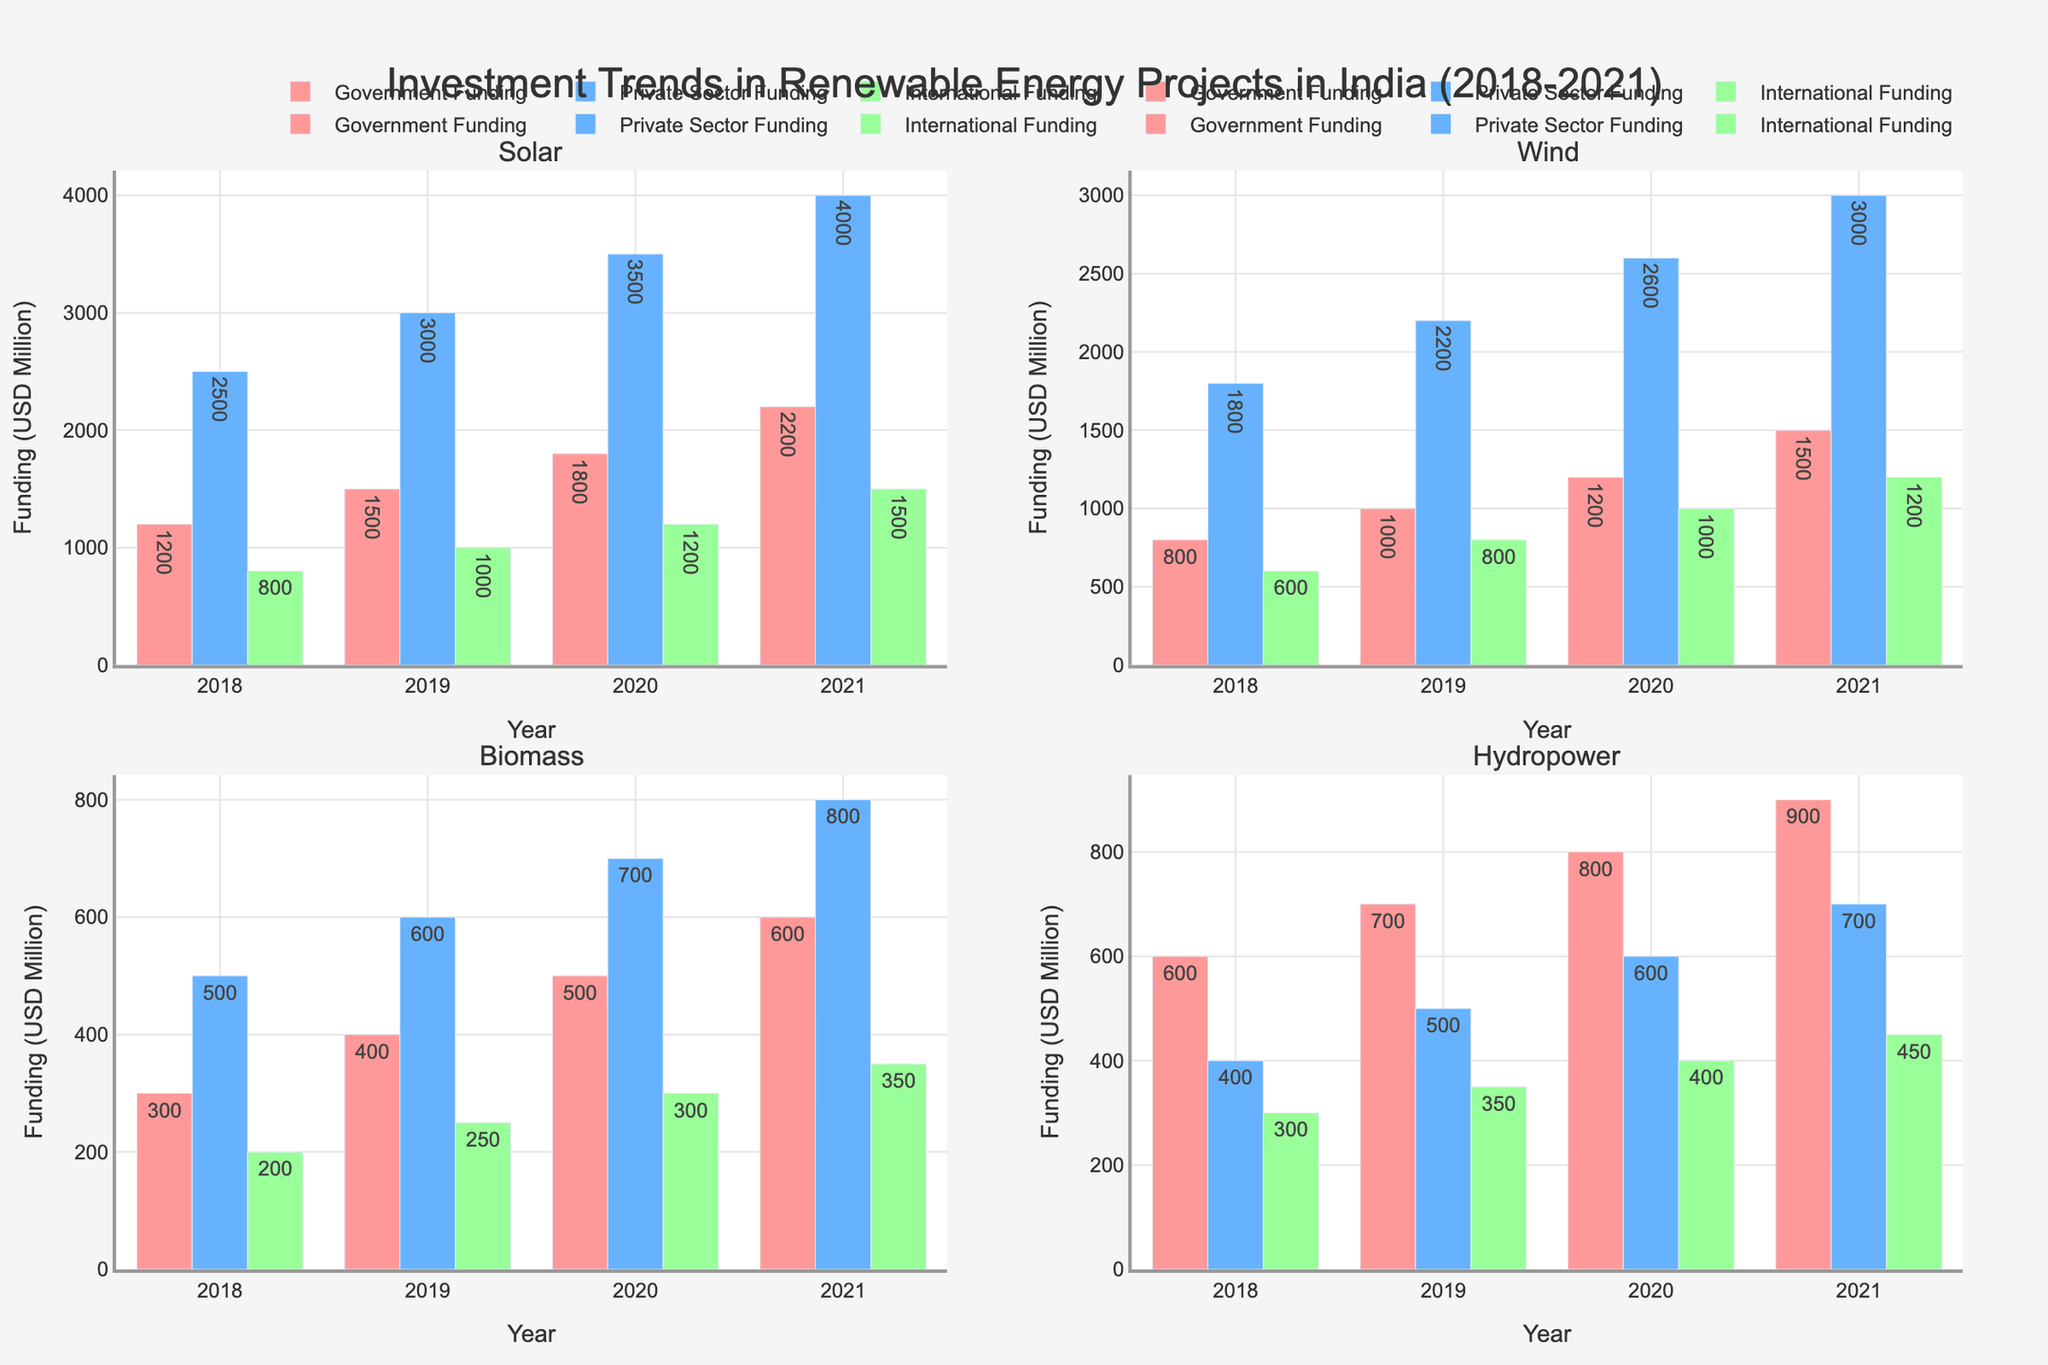What is the overall trend in government funding for solar energy from 2018 to 2021? Government funding for solar energy increased steadily from 1200 million USD in 2018 to 2200 million USD in 2021.
Answer: Increasing Which funding source for biomass energy saw the smallest change from 2018 to 2021? Private sector funding for biomass energy experienced the smallest change, increasing only from 500 million USD in 2018 to 800 million USD in 2021.
Answer: Private sector Among the energy types, which one had the highest international funding in 2021? By examining the subplot for 2021, it's evident that solar energy had the highest international funding at 1500 million USD.
Answer: Solar Compare the private sector funding for wind energy between 2018 and 2021. What is the difference? In 2018, the private sector funding for wind energy was 1800 million USD. In 2021, it was 3000 million USD. The difference is 3000 - 1800 = 1200 million USD.
Answer: 1200 million USD Which year had the highest total investment (sum of all funding sources) for hydropower? To find this, we sum the funding for hydropower from government, private sector, and international sources for each year. For 2021, the total is 900 (government) + 700 (private sector) + 450 (international) = 2050 million USD. This is the highest among all years.
Answer: 2021 Is the government funding for wind energy in 2020 higher or lower compared to hydropower in the same year? Government funding for wind energy in 2020 was 1200 million USD, while for hydropower it was 800 million USD. Thus, wind energy had higher government funding in 2020 compared to hydropower.
Answer: Higher Which energy type had the most consistent international funding amounts from 2018 to 2021? Biomass energy had international funding amounts of 200, 250, 300, and 350 million USD from 2018 to 2021, showing the most consistent increase.
Answer: Biomass What was the total private sector funding for solar energy over the four years from 2018 to 2021? Private sector funding for solar energy was 2500 million USD in 2018, 3000 million USD in 2019, 3500 million USD in 2020, and 4000 million USD in 2021. The total is 2500 + 3000 + 3500 + 4000 = 13000 million USD.
Answer: 13000 million USD How does the international funding for wind energy in 2021 compare to government funding for biomass energy in the same year? International funding for wind energy in 2021 was 1200 million USD, while government funding for biomass energy was 600 million USD. The international funding for wind energy was higher.
Answer: Higher 